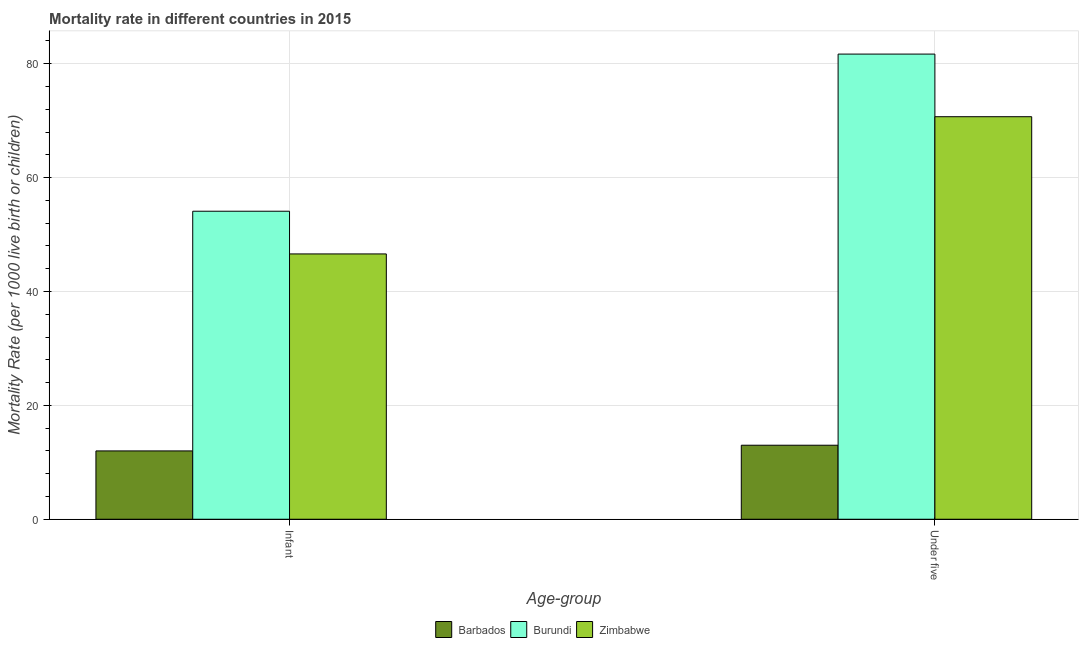How many different coloured bars are there?
Your response must be concise. 3. How many bars are there on the 1st tick from the left?
Ensure brevity in your answer.  3. What is the label of the 1st group of bars from the left?
Give a very brief answer. Infant. What is the under-5 mortality rate in Zimbabwe?
Make the answer very short. 70.7. Across all countries, what is the maximum under-5 mortality rate?
Offer a terse response. 81.7. In which country was the under-5 mortality rate maximum?
Offer a terse response. Burundi. In which country was the under-5 mortality rate minimum?
Keep it short and to the point. Barbados. What is the total infant mortality rate in the graph?
Offer a very short reply. 112.7. What is the difference between the infant mortality rate in Zimbabwe and the under-5 mortality rate in Barbados?
Keep it short and to the point. 33.6. What is the average infant mortality rate per country?
Make the answer very short. 37.57. What is the difference between the under-5 mortality rate and infant mortality rate in Zimbabwe?
Offer a terse response. 24.1. In how many countries, is the infant mortality rate greater than 24 ?
Make the answer very short. 2. What is the ratio of the infant mortality rate in Barbados to that in Burundi?
Offer a terse response. 0.22. Is the infant mortality rate in Burundi less than that in Barbados?
Make the answer very short. No. In how many countries, is the under-5 mortality rate greater than the average under-5 mortality rate taken over all countries?
Keep it short and to the point. 2. What does the 1st bar from the left in Under five represents?
Provide a succinct answer. Barbados. What does the 1st bar from the right in Infant represents?
Your answer should be compact. Zimbabwe. Are all the bars in the graph horizontal?
Keep it short and to the point. No. How many countries are there in the graph?
Offer a very short reply. 3. Are the values on the major ticks of Y-axis written in scientific E-notation?
Your response must be concise. No. Does the graph contain any zero values?
Give a very brief answer. No. How many legend labels are there?
Provide a short and direct response. 3. How are the legend labels stacked?
Offer a terse response. Horizontal. What is the title of the graph?
Your answer should be compact. Mortality rate in different countries in 2015. What is the label or title of the X-axis?
Provide a short and direct response. Age-group. What is the label or title of the Y-axis?
Keep it short and to the point. Mortality Rate (per 1000 live birth or children). What is the Mortality Rate (per 1000 live birth or children) of Barbados in Infant?
Your answer should be very brief. 12. What is the Mortality Rate (per 1000 live birth or children) in Burundi in Infant?
Provide a short and direct response. 54.1. What is the Mortality Rate (per 1000 live birth or children) in Zimbabwe in Infant?
Keep it short and to the point. 46.6. What is the Mortality Rate (per 1000 live birth or children) in Barbados in Under five?
Give a very brief answer. 13. What is the Mortality Rate (per 1000 live birth or children) of Burundi in Under five?
Give a very brief answer. 81.7. What is the Mortality Rate (per 1000 live birth or children) of Zimbabwe in Under five?
Provide a short and direct response. 70.7. Across all Age-group, what is the maximum Mortality Rate (per 1000 live birth or children) in Barbados?
Offer a terse response. 13. Across all Age-group, what is the maximum Mortality Rate (per 1000 live birth or children) in Burundi?
Keep it short and to the point. 81.7. Across all Age-group, what is the maximum Mortality Rate (per 1000 live birth or children) in Zimbabwe?
Offer a very short reply. 70.7. Across all Age-group, what is the minimum Mortality Rate (per 1000 live birth or children) in Burundi?
Offer a very short reply. 54.1. Across all Age-group, what is the minimum Mortality Rate (per 1000 live birth or children) in Zimbabwe?
Your answer should be very brief. 46.6. What is the total Mortality Rate (per 1000 live birth or children) in Burundi in the graph?
Your answer should be compact. 135.8. What is the total Mortality Rate (per 1000 live birth or children) in Zimbabwe in the graph?
Your answer should be very brief. 117.3. What is the difference between the Mortality Rate (per 1000 live birth or children) in Barbados in Infant and that in Under five?
Provide a short and direct response. -1. What is the difference between the Mortality Rate (per 1000 live birth or children) of Burundi in Infant and that in Under five?
Ensure brevity in your answer.  -27.6. What is the difference between the Mortality Rate (per 1000 live birth or children) in Zimbabwe in Infant and that in Under five?
Keep it short and to the point. -24.1. What is the difference between the Mortality Rate (per 1000 live birth or children) of Barbados in Infant and the Mortality Rate (per 1000 live birth or children) of Burundi in Under five?
Make the answer very short. -69.7. What is the difference between the Mortality Rate (per 1000 live birth or children) of Barbados in Infant and the Mortality Rate (per 1000 live birth or children) of Zimbabwe in Under five?
Your response must be concise. -58.7. What is the difference between the Mortality Rate (per 1000 live birth or children) of Burundi in Infant and the Mortality Rate (per 1000 live birth or children) of Zimbabwe in Under five?
Your answer should be very brief. -16.6. What is the average Mortality Rate (per 1000 live birth or children) of Burundi per Age-group?
Make the answer very short. 67.9. What is the average Mortality Rate (per 1000 live birth or children) of Zimbabwe per Age-group?
Give a very brief answer. 58.65. What is the difference between the Mortality Rate (per 1000 live birth or children) of Barbados and Mortality Rate (per 1000 live birth or children) of Burundi in Infant?
Make the answer very short. -42.1. What is the difference between the Mortality Rate (per 1000 live birth or children) in Barbados and Mortality Rate (per 1000 live birth or children) in Zimbabwe in Infant?
Keep it short and to the point. -34.6. What is the difference between the Mortality Rate (per 1000 live birth or children) of Burundi and Mortality Rate (per 1000 live birth or children) of Zimbabwe in Infant?
Give a very brief answer. 7.5. What is the difference between the Mortality Rate (per 1000 live birth or children) of Barbados and Mortality Rate (per 1000 live birth or children) of Burundi in Under five?
Offer a very short reply. -68.7. What is the difference between the Mortality Rate (per 1000 live birth or children) in Barbados and Mortality Rate (per 1000 live birth or children) in Zimbabwe in Under five?
Give a very brief answer. -57.7. What is the difference between the Mortality Rate (per 1000 live birth or children) of Burundi and Mortality Rate (per 1000 live birth or children) of Zimbabwe in Under five?
Provide a succinct answer. 11. What is the ratio of the Mortality Rate (per 1000 live birth or children) of Burundi in Infant to that in Under five?
Give a very brief answer. 0.66. What is the ratio of the Mortality Rate (per 1000 live birth or children) of Zimbabwe in Infant to that in Under five?
Keep it short and to the point. 0.66. What is the difference between the highest and the second highest Mortality Rate (per 1000 live birth or children) in Burundi?
Your answer should be very brief. 27.6. What is the difference between the highest and the second highest Mortality Rate (per 1000 live birth or children) in Zimbabwe?
Your answer should be very brief. 24.1. What is the difference between the highest and the lowest Mortality Rate (per 1000 live birth or children) in Barbados?
Give a very brief answer. 1. What is the difference between the highest and the lowest Mortality Rate (per 1000 live birth or children) in Burundi?
Your response must be concise. 27.6. What is the difference between the highest and the lowest Mortality Rate (per 1000 live birth or children) in Zimbabwe?
Offer a terse response. 24.1. 